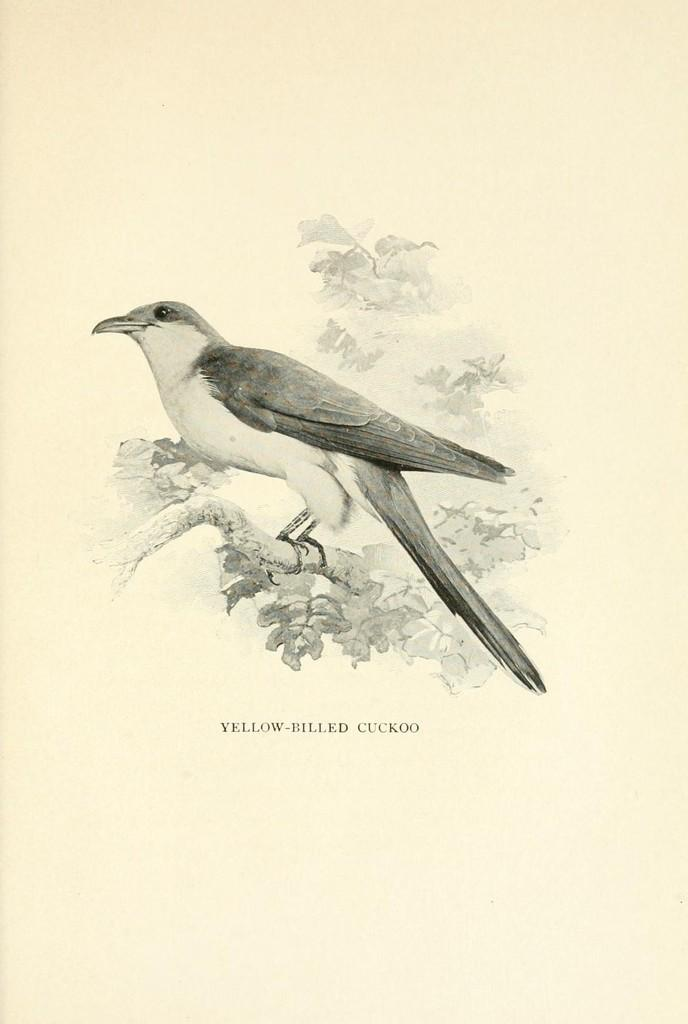What is the main subject of the image? The main subject of the image is a black and white picture of a bird. Where is the bird located in the image? The bird is on a tree branch in the image. What else is present on the image besides the bird? There is text on the image. What type of verse can be seen written on the bird's card in the image? There is no card or verse present in the image; it features a black and white picture of a bird and text. What is the bird using to store its food in the image? There is no jar or food storage item present in the image; it only shows a bird on a tree branch and text. 